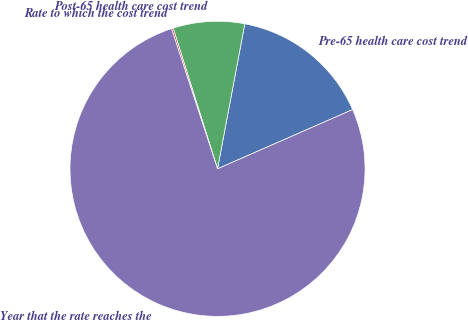Convert chart to OTSL. <chart><loc_0><loc_0><loc_500><loc_500><pie_chart><fcel>Pre-65 health care cost trend<fcel>Post-65 health care cost trend<fcel>Rate to which the cost trend<fcel>Year that the rate reaches the<nl><fcel>15.46%<fcel>7.82%<fcel>0.19%<fcel>76.53%<nl></chart> 